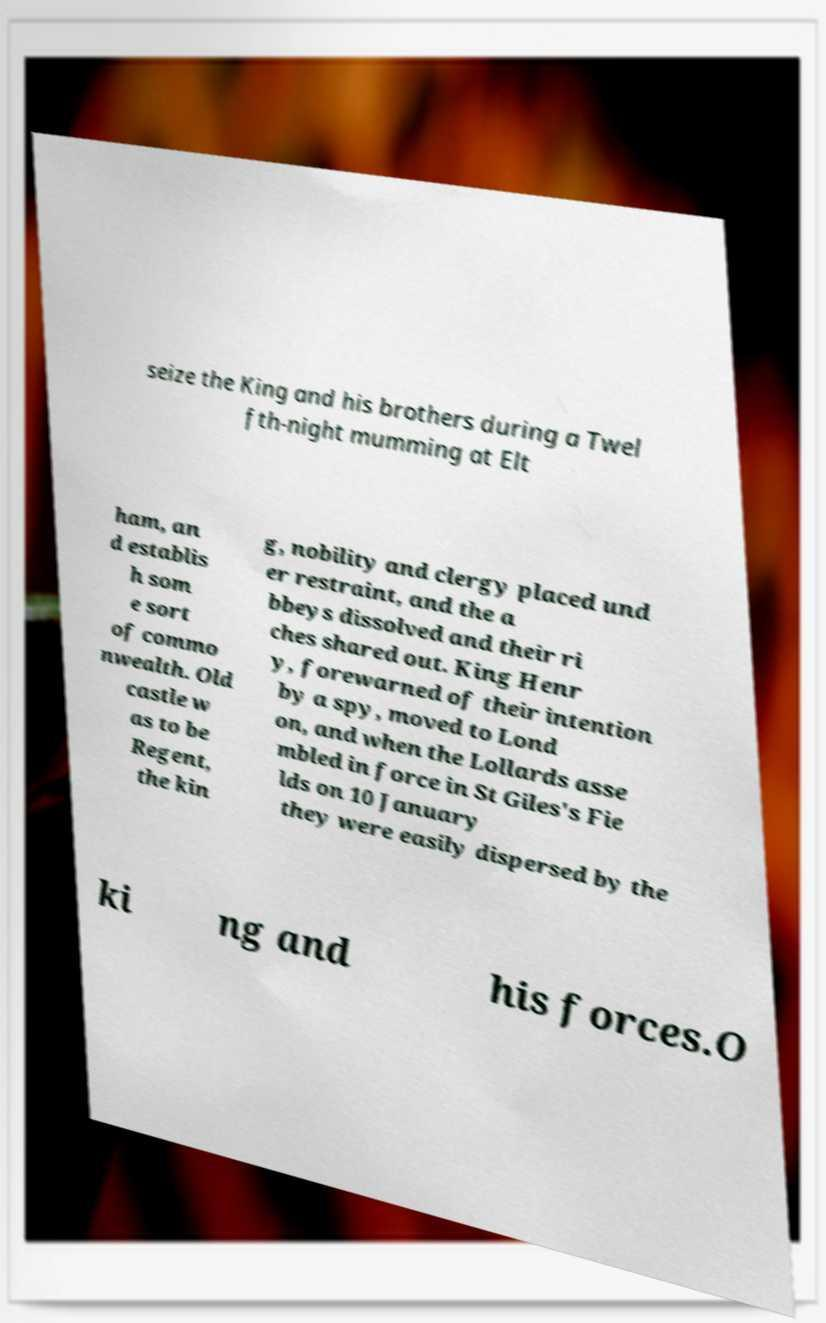Please read and relay the text visible in this image. What does it say? seize the King and his brothers during a Twel fth-night mumming at Elt ham, an d establis h som e sort of commo nwealth. Old castle w as to be Regent, the kin g, nobility and clergy placed und er restraint, and the a bbeys dissolved and their ri ches shared out. King Henr y, forewarned of their intention by a spy, moved to Lond on, and when the Lollards asse mbled in force in St Giles's Fie lds on 10 January they were easily dispersed by the ki ng and his forces.O 